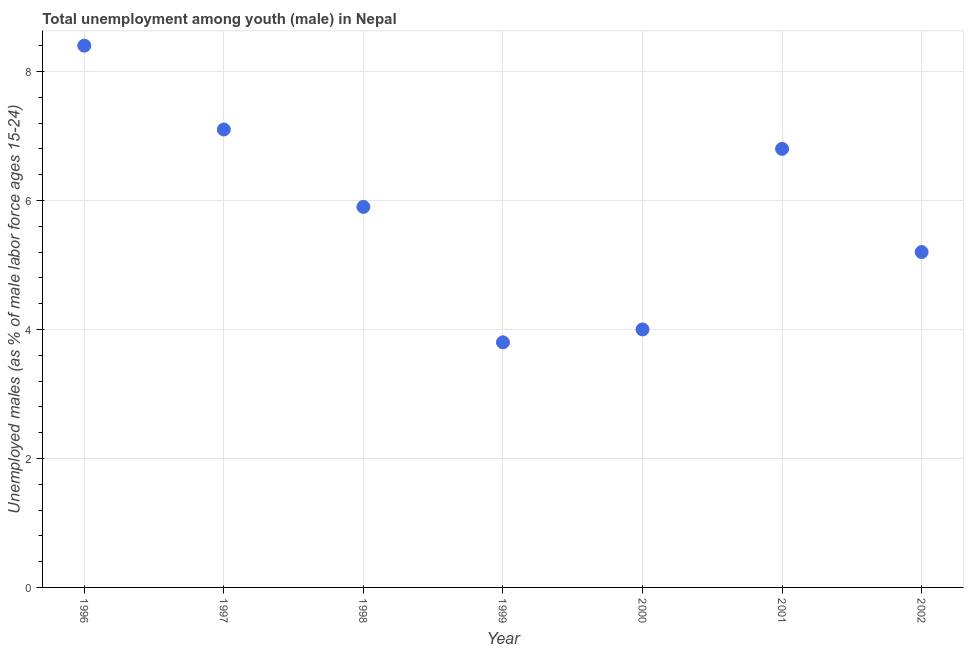What is the unemployed male youth population in 1999?
Offer a terse response. 3.8. Across all years, what is the maximum unemployed male youth population?
Offer a very short reply. 8.4. Across all years, what is the minimum unemployed male youth population?
Your answer should be compact. 3.8. In which year was the unemployed male youth population maximum?
Offer a terse response. 1996. In which year was the unemployed male youth population minimum?
Your response must be concise. 1999. What is the sum of the unemployed male youth population?
Provide a succinct answer. 41.2. What is the difference between the unemployed male youth population in 1998 and 2000?
Give a very brief answer. 1.9. What is the average unemployed male youth population per year?
Provide a short and direct response. 5.89. What is the median unemployed male youth population?
Make the answer very short. 5.9. In how many years, is the unemployed male youth population greater than 0.8 %?
Provide a succinct answer. 7. What is the ratio of the unemployed male youth population in 1997 to that in 2002?
Give a very brief answer. 1.37. What is the difference between the highest and the second highest unemployed male youth population?
Offer a very short reply. 1.3. What is the difference between the highest and the lowest unemployed male youth population?
Provide a succinct answer. 4.6. In how many years, is the unemployed male youth population greater than the average unemployed male youth population taken over all years?
Your answer should be very brief. 4. Does the unemployed male youth population monotonically increase over the years?
Offer a very short reply. No. What is the difference between two consecutive major ticks on the Y-axis?
Make the answer very short. 2. Does the graph contain any zero values?
Keep it short and to the point. No. What is the title of the graph?
Provide a succinct answer. Total unemployment among youth (male) in Nepal. What is the label or title of the X-axis?
Provide a succinct answer. Year. What is the label or title of the Y-axis?
Provide a short and direct response. Unemployed males (as % of male labor force ages 15-24). What is the Unemployed males (as % of male labor force ages 15-24) in 1996?
Ensure brevity in your answer.  8.4. What is the Unemployed males (as % of male labor force ages 15-24) in 1997?
Your response must be concise. 7.1. What is the Unemployed males (as % of male labor force ages 15-24) in 1998?
Provide a short and direct response. 5.9. What is the Unemployed males (as % of male labor force ages 15-24) in 1999?
Offer a terse response. 3.8. What is the Unemployed males (as % of male labor force ages 15-24) in 2001?
Provide a succinct answer. 6.8. What is the Unemployed males (as % of male labor force ages 15-24) in 2002?
Make the answer very short. 5.2. What is the difference between the Unemployed males (as % of male labor force ages 15-24) in 1996 and 1997?
Your answer should be very brief. 1.3. What is the difference between the Unemployed males (as % of male labor force ages 15-24) in 1996 and 1999?
Your response must be concise. 4.6. What is the difference between the Unemployed males (as % of male labor force ages 15-24) in 1996 and 2000?
Your answer should be very brief. 4.4. What is the difference between the Unemployed males (as % of male labor force ages 15-24) in 1996 and 2001?
Make the answer very short. 1.6. What is the difference between the Unemployed males (as % of male labor force ages 15-24) in 1997 and 1999?
Offer a terse response. 3.3. What is the difference between the Unemployed males (as % of male labor force ages 15-24) in 1998 and 1999?
Keep it short and to the point. 2.1. What is the difference between the Unemployed males (as % of male labor force ages 15-24) in 1998 and 2001?
Keep it short and to the point. -0.9. What is the difference between the Unemployed males (as % of male labor force ages 15-24) in 1999 and 2000?
Keep it short and to the point. -0.2. What is the difference between the Unemployed males (as % of male labor force ages 15-24) in 1999 and 2001?
Keep it short and to the point. -3. What is the difference between the Unemployed males (as % of male labor force ages 15-24) in 2000 and 2001?
Provide a succinct answer. -2.8. What is the ratio of the Unemployed males (as % of male labor force ages 15-24) in 1996 to that in 1997?
Keep it short and to the point. 1.18. What is the ratio of the Unemployed males (as % of male labor force ages 15-24) in 1996 to that in 1998?
Make the answer very short. 1.42. What is the ratio of the Unemployed males (as % of male labor force ages 15-24) in 1996 to that in 1999?
Make the answer very short. 2.21. What is the ratio of the Unemployed males (as % of male labor force ages 15-24) in 1996 to that in 2001?
Offer a very short reply. 1.24. What is the ratio of the Unemployed males (as % of male labor force ages 15-24) in 1996 to that in 2002?
Your answer should be compact. 1.61. What is the ratio of the Unemployed males (as % of male labor force ages 15-24) in 1997 to that in 1998?
Provide a succinct answer. 1.2. What is the ratio of the Unemployed males (as % of male labor force ages 15-24) in 1997 to that in 1999?
Give a very brief answer. 1.87. What is the ratio of the Unemployed males (as % of male labor force ages 15-24) in 1997 to that in 2000?
Provide a succinct answer. 1.77. What is the ratio of the Unemployed males (as % of male labor force ages 15-24) in 1997 to that in 2001?
Provide a short and direct response. 1.04. What is the ratio of the Unemployed males (as % of male labor force ages 15-24) in 1997 to that in 2002?
Provide a short and direct response. 1.36. What is the ratio of the Unemployed males (as % of male labor force ages 15-24) in 1998 to that in 1999?
Offer a very short reply. 1.55. What is the ratio of the Unemployed males (as % of male labor force ages 15-24) in 1998 to that in 2000?
Your answer should be compact. 1.48. What is the ratio of the Unemployed males (as % of male labor force ages 15-24) in 1998 to that in 2001?
Make the answer very short. 0.87. What is the ratio of the Unemployed males (as % of male labor force ages 15-24) in 1998 to that in 2002?
Your answer should be compact. 1.14. What is the ratio of the Unemployed males (as % of male labor force ages 15-24) in 1999 to that in 2000?
Your answer should be very brief. 0.95. What is the ratio of the Unemployed males (as % of male labor force ages 15-24) in 1999 to that in 2001?
Ensure brevity in your answer.  0.56. What is the ratio of the Unemployed males (as % of male labor force ages 15-24) in 1999 to that in 2002?
Make the answer very short. 0.73. What is the ratio of the Unemployed males (as % of male labor force ages 15-24) in 2000 to that in 2001?
Offer a very short reply. 0.59. What is the ratio of the Unemployed males (as % of male labor force ages 15-24) in 2000 to that in 2002?
Offer a terse response. 0.77. What is the ratio of the Unemployed males (as % of male labor force ages 15-24) in 2001 to that in 2002?
Offer a very short reply. 1.31. 